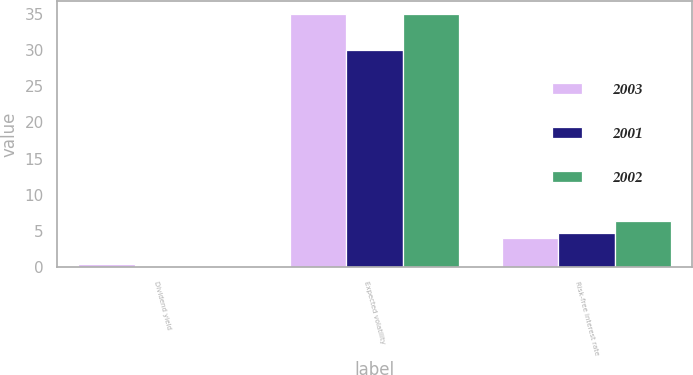<chart> <loc_0><loc_0><loc_500><loc_500><stacked_bar_chart><ecel><fcel>Dividend yield<fcel>Expected volatility<fcel>Risk-free interest rate<nl><fcel>2003<fcel>0.38<fcel>35<fcel>4.02<nl><fcel>2001<fcel>0<fcel>30<fcel>4.78<nl><fcel>2002<fcel>0<fcel>35<fcel>6.42<nl></chart> 